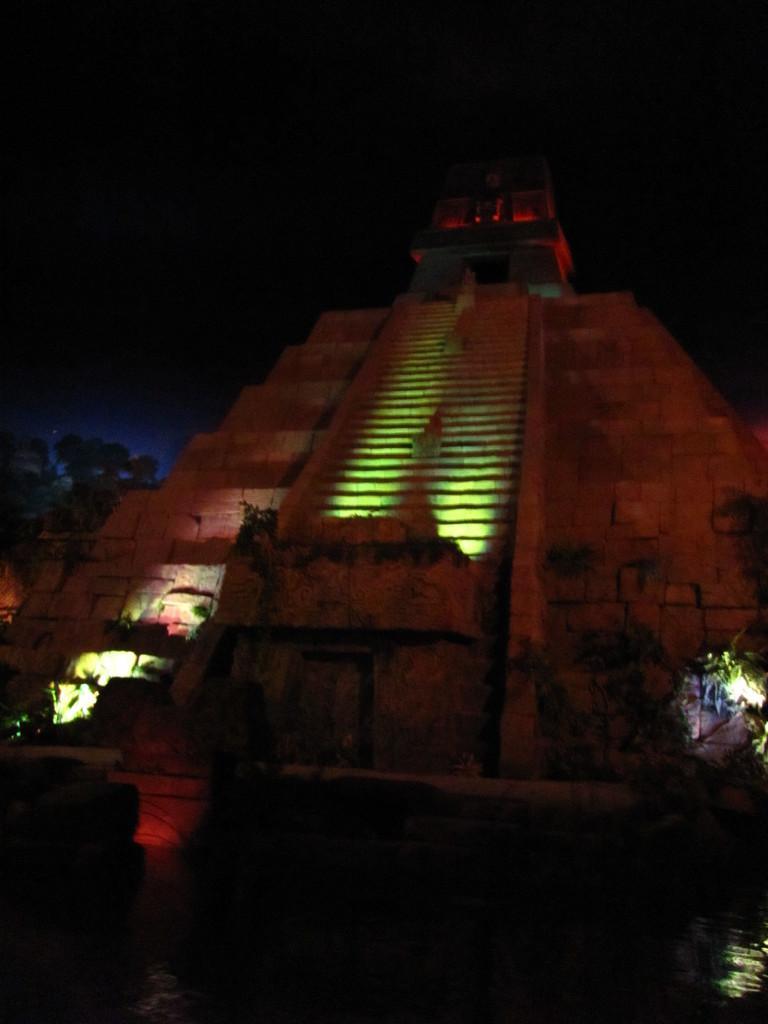Can you describe this image briefly? In the foreground I can see water, pillar, lights, trees, steps and a building. In the background I can see the sky. This image is taken may be during night. 